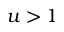Convert formula to latex. <formula><loc_0><loc_0><loc_500><loc_500>u > 1</formula> 